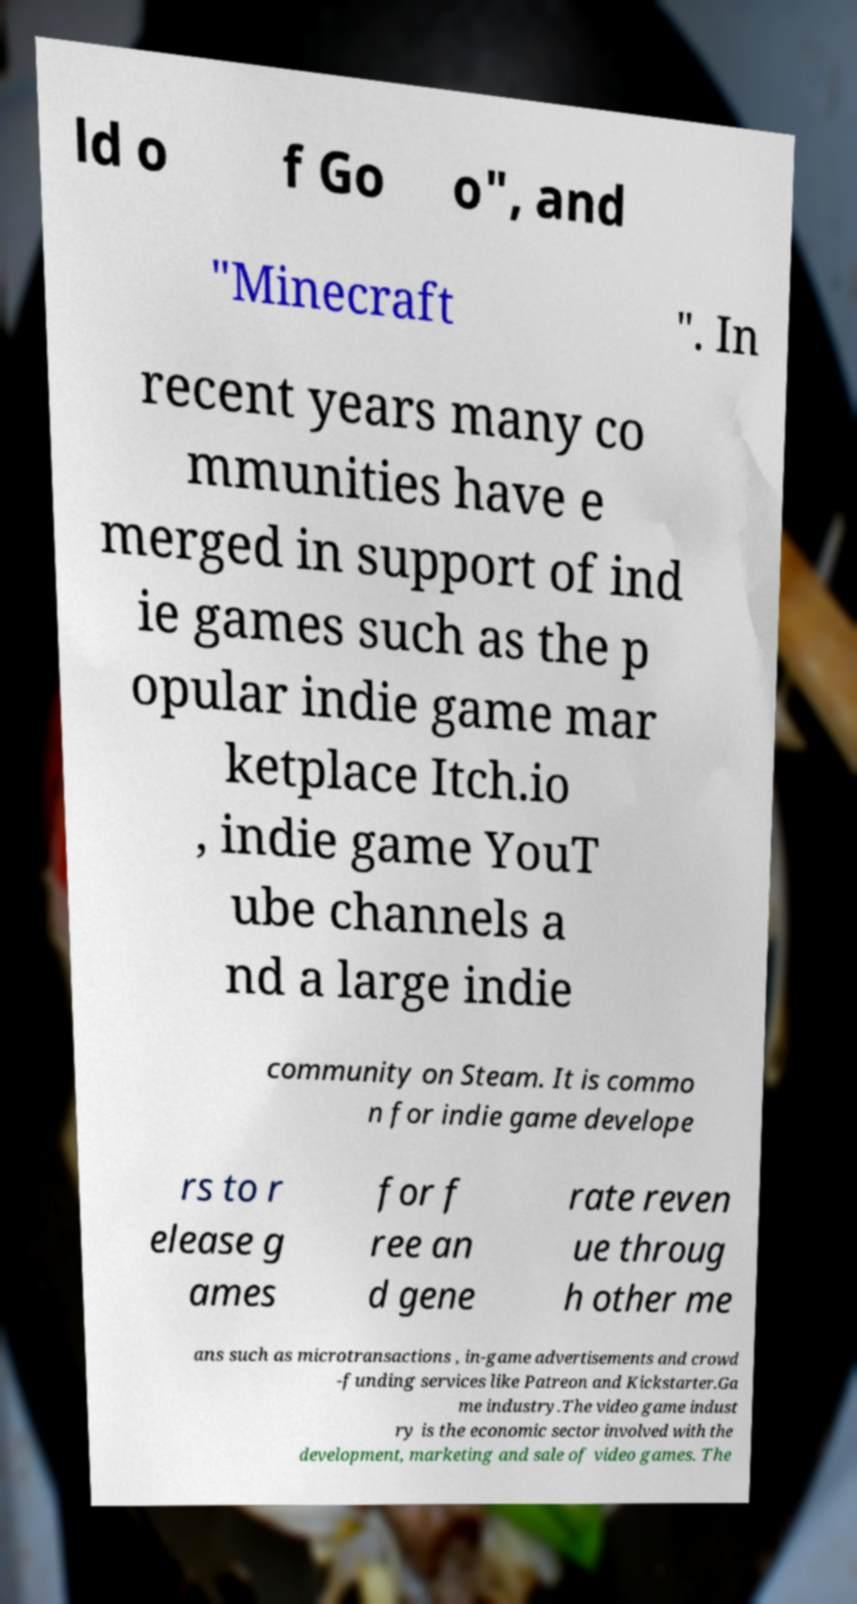I need the written content from this picture converted into text. Can you do that? ld o f Go o", and "Minecraft ". In recent years many co mmunities have e merged in support of ind ie games such as the p opular indie game mar ketplace Itch.io , indie game YouT ube channels a nd a large indie community on Steam. It is commo n for indie game develope rs to r elease g ames for f ree an d gene rate reven ue throug h other me ans such as microtransactions , in-game advertisements and crowd -funding services like Patreon and Kickstarter.Ga me industry.The video game indust ry is the economic sector involved with the development, marketing and sale of video games. The 